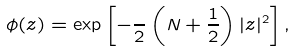Convert formula to latex. <formula><loc_0><loc_0><loc_500><loc_500>\phi ( z ) = \exp \left [ - \frac { } { 2 } \left ( N + \frac { 1 } { 2 } \right ) | z | ^ { 2 } \right ] ,</formula> 